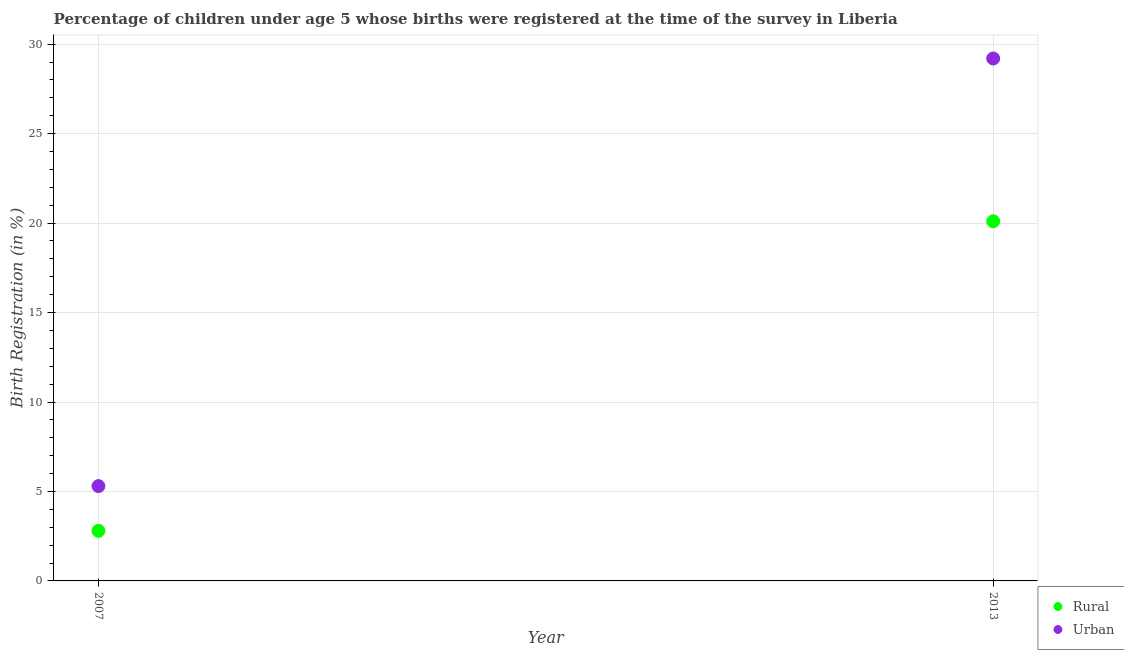How many different coloured dotlines are there?
Provide a short and direct response. 2. Is the number of dotlines equal to the number of legend labels?
Your answer should be compact. Yes. What is the rural birth registration in 2013?
Ensure brevity in your answer.  20.1. Across all years, what is the maximum rural birth registration?
Your answer should be very brief. 20.1. In which year was the rural birth registration maximum?
Make the answer very short. 2013. What is the total urban birth registration in the graph?
Your answer should be compact. 34.5. What is the difference between the urban birth registration in 2007 and that in 2013?
Ensure brevity in your answer.  -23.9. What is the difference between the urban birth registration in 2007 and the rural birth registration in 2013?
Your answer should be very brief. -14.8. What is the average rural birth registration per year?
Your answer should be very brief. 11.45. What is the ratio of the rural birth registration in 2007 to that in 2013?
Give a very brief answer. 0.14. Is the rural birth registration in 2007 less than that in 2013?
Give a very brief answer. Yes. Are the values on the major ticks of Y-axis written in scientific E-notation?
Make the answer very short. No. Where does the legend appear in the graph?
Provide a succinct answer. Bottom right. How many legend labels are there?
Your answer should be very brief. 2. What is the title of the graph?
Make the answer very short. Percentage of children under age 5 whose births were registered at the time of the survey in Liberia. Does "Study and work" appear as one of the legend labels in the graph?
Ensure brevity in your answer.  No. What is the label or title of the X-axis?
Give a very brief answer. Year. What is the label or title of the Y-axis?
Offer a very short reply. Birth Registration (in %). What is the Birth Registration (in %) of Rural in 2007?
Make the answer very short. 2.8. What is the Birth Registration (in %) of Rural in 2013?
Provide a short and direct response. 20.1. What is the Birth Registration (in %) of Urban in 2013?
Your answer should be compact. 29.2. Across all years, what is the maximum Birth Registration (in %) of Rural?
Make the answer very short. 20.1. Across all years, what is the maximum Birth Registration (in %) in Urban?
Give a very brief answer. 29.2. What is the total Birth Registration (in %) in Rural in the graph?
Ensure brevity in your answer.  22.9. What is the total Birth Registration (in %) in Urban in the graph?
Make the answer very short. 34.5. What is the difference between the Birth Registration (in %) of Rural in 2007 and that in 2013?
Provide a short and direct response. -17.3. What is the difference between the Birth Registration (in %) in Urban in 2007 and that in 2013?
Make the answer very short. -23.9. What is the difference between the Birth Registration (in %) in Rural in 2007 and the Birth Registration (in %) in Urban in 2013?
Make the answer very short. -26.4. What is the average Birth Registration (in %) of Rural per year?
Make the answer very short. 11.45. What is the average Birth Registration (in %) of Urban per year?
Your answer should be compact. 17.25. What is the ratio of the Birth Registration (in %) of Rural in 2007 to that in 2013?
Your answer should be very brief. 0.14. What is the ratio of the Birth Registration (in %) in Urban in 2007 to that in 2013?
Your response must be concise. 0.18. What is the difference between the highest and the second highest Birth Registration (in %) in Rural?
Provide a succinct answer. 17.3. What is the difference between the highest and the second highest Birth Registration (in %) in Urban?
Ensure brevity in your answer.  23.9. What is the difference between the highest and the lowest Birth Registration (in %) of Urban?
Your response must be concise. 23.9. 